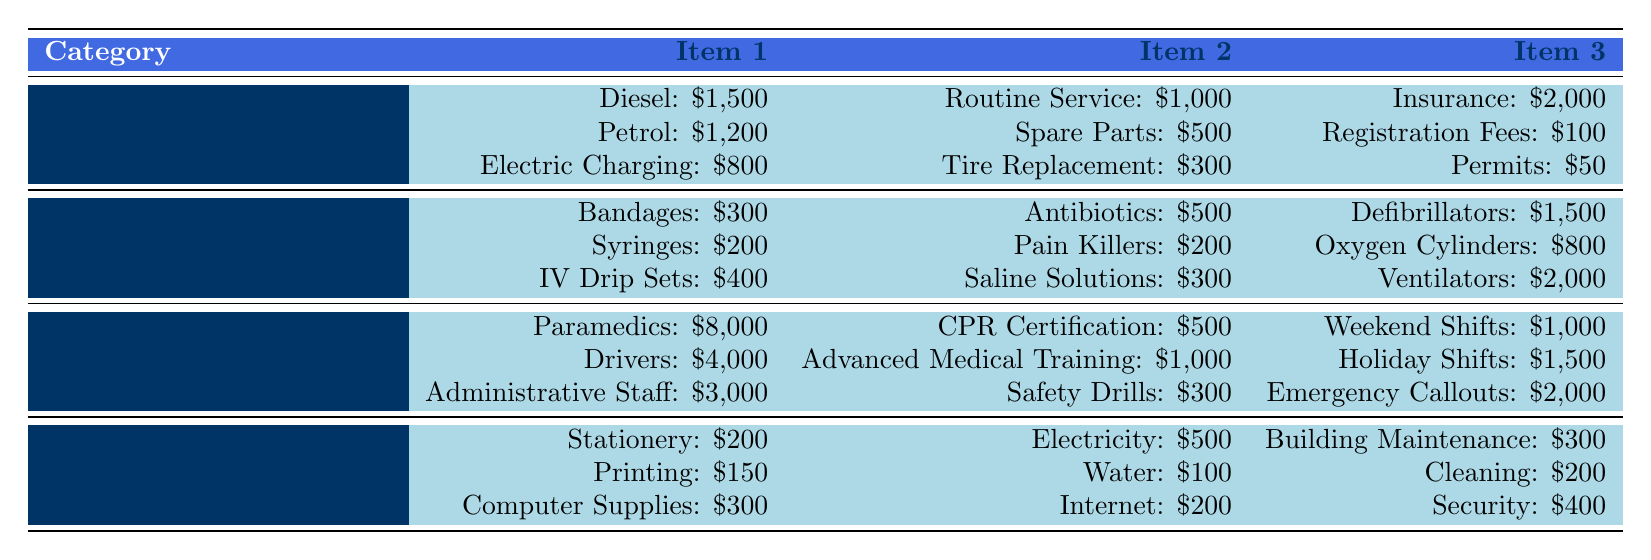What is the total expense for Ambulance Operations? To find the total expense, we add the expenses from each category under Ambulance Operations. The total is calculated as follows: 1500 (Diesel) + 1200 (Petrol) + 800 (Electric Charging) + 1000 (Routine Service) + 500 (Spare Parts) + 300 (Tire Replacement) + 2000 (Insurance) + 100 (Registration Fees) + 50 (Permits) = 6050.
Answer: 6050 Which item under Medical Supplies has the highest expense? By examining the Medical Supplies section, we identify the expenses for each item: Bandages (300), Antibiotics (500), Defibrillators (1500), Syringes (200), Pain Killers (200), Oxygen Cylinders (800), IV Drip Sets (400), Saline Solutions (300), and Ventilators (2000). Ventilators has the highest expense at 2000.
Answer: Ventilators Is the total Overtime expense greater than the total Utility expenses? First, we calculate the total Overtime expense: 1000 (Weekend Shifts) + 1500 (Holiday Shifts) + 2000 (Emergency Callouts) = 4500. Then, we calculate the total Utility expenses: 500 (Electricity) + 100 (Water) + 200 (Internet) = 800. Since 4500 is greater than 800, the answer is yes.
Answer: Yes What is the average expense for the Personnel Costs? To find the average expense, we sum the individual expenses: 8000 (Paramedics) + 4000 (Drivers) + 3000 (Administrative Staff) + 500 (CPR Certification) + 1000 (Advanced Medical Training) + 300 (Safety Drills) + 1000 (Weekend Shifts) + 1500 (Holiday Shifts) + 2000 (Emergency Callouts) = 15700. There are 9 individual expenses, so the average is 15700 / 9 ≈ 1744.44.
Answer: 1744.44 Is the combined expense for Administrative Expenses higher than the total expense for Medical Supplies? First, we calculate Administrative Expenses total: 200 (Stationery) + 150 (Printing) + 300 (Computer Supplies) + 500 (Electricity) + 100 (Water) + 200 (Internet) + 300 (Building Maintenance) + 200 (Cleaning) + 400 (Security) = 1850. Medical Supplies total is 300 (Bandages) + 200 (Syringes) + 400 (IV Drip Sets) + 500 (Antibiotics) + 200 (Pain Killers) + 300 (Saline Solutions) + 1500 (Defibrillators) + 800 (Oxygen Cylinders) + 2000 (Ventilators) = 6200. Since 1850 is less than 6200, the answer is no.
Answer: No What is the total expense for Utilities in the Ambulance Operations? The expenses for Utilities are provided as follows: 2000 (Insurance) + 100 (Registration Fees) + 50 (Permits). Adding these amounts gives us 2000 + 100 + 50 = 2150.
Answer: 2150 